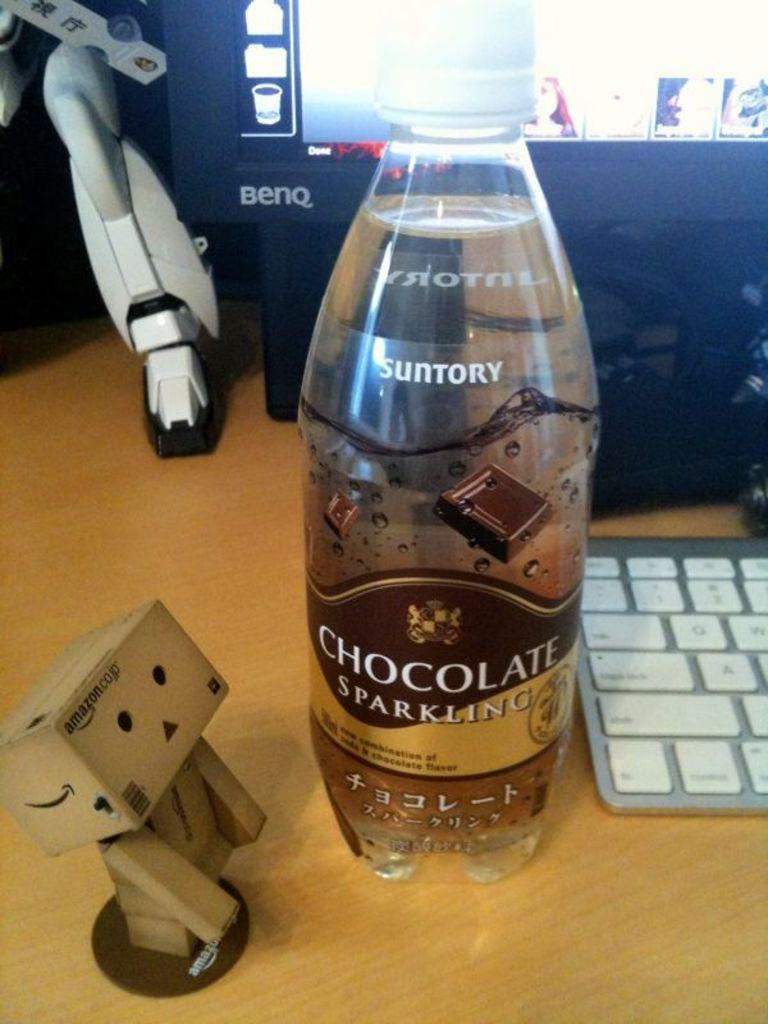<image>
Provide a brief description of the given image. A bottle of Suntory Chocolate Sparkling soda next to a computer keyboard 